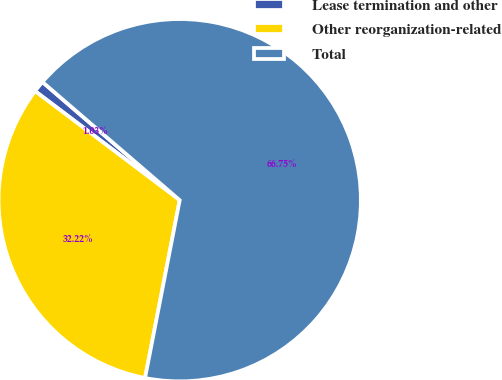Convert chart. <chart><loc_0><loc_0><loc_500><loc_500><pie_chart><fcel>Lease termination and other<fcel>Other reorganization-related<fcel>Total<nl><fcel>1.03%<fcel>32.22%<fcel>66.75%<nl></chart> 